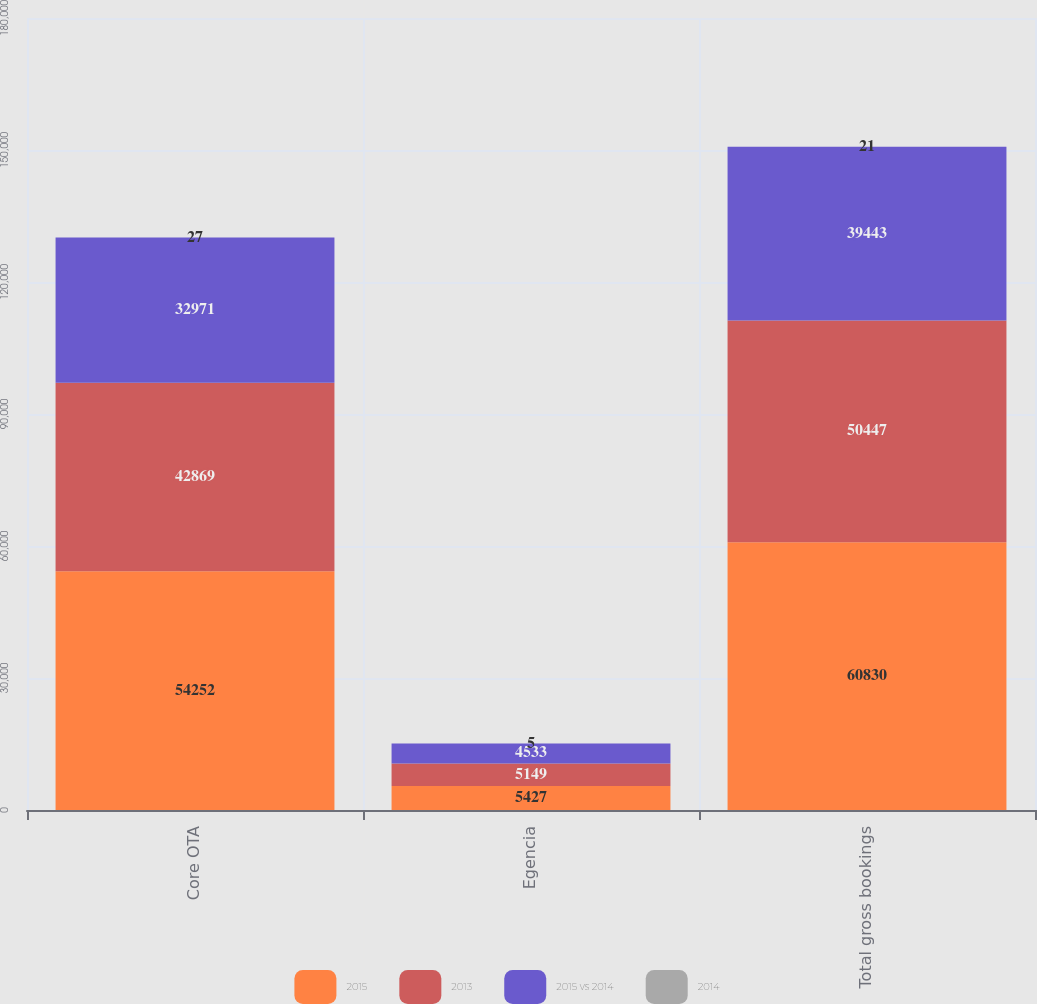Convert chart to OTSL. <chart><loc_0><loc_0><loc_500><loc_500><stacked_bar_chart><ecel><fcel>Core OTA<fcel>Egencia<fcel>Total gross bookings<nl><fcel>2015<fcel>54252<fcel>5427<fcel>60830<nl><fcel>2013<fcel>42869<fcel>5149<fcel>50447<nl><fcel>2015 vs 2014<fcel>32971<fcel>4533<fcel>39443<nl><fcel>2014<fcel>27<fcel>5<fcel>21<nl></chart> 